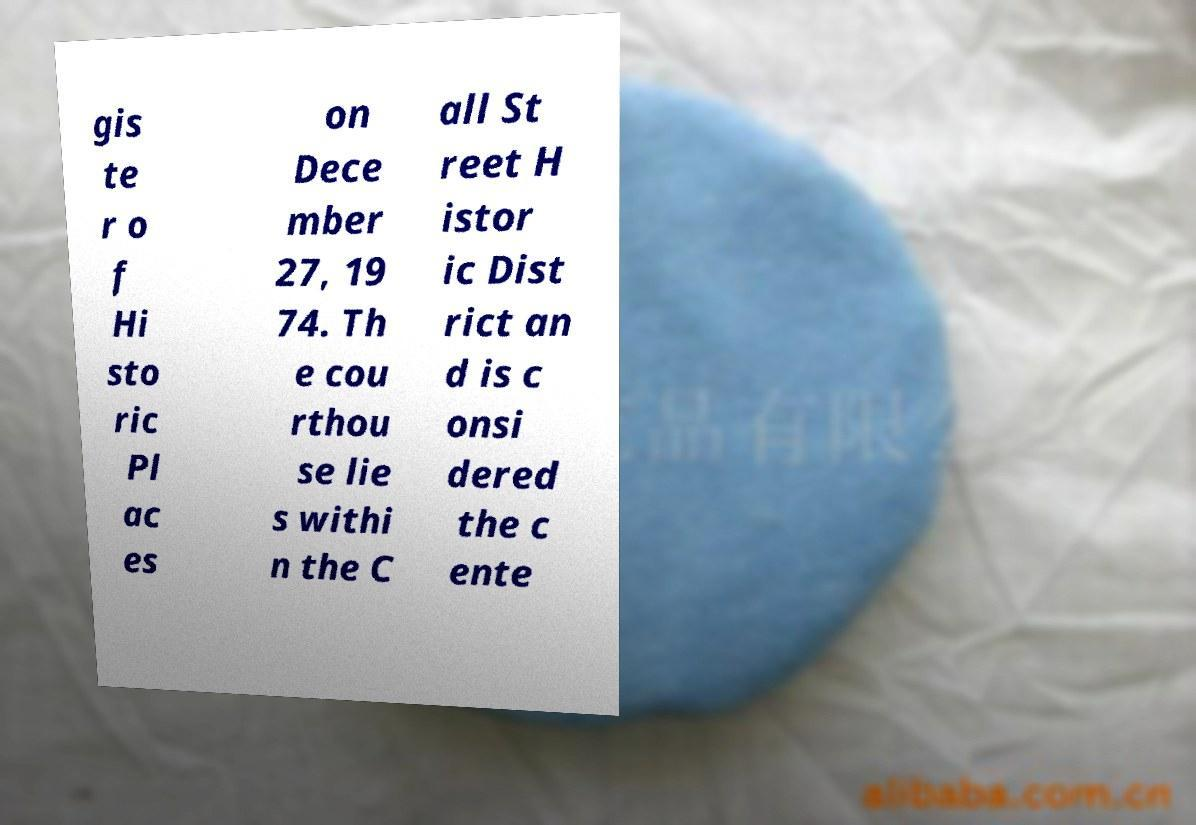Can you read and provide the text displayed in the image?This photo seems to have some interesting text. Can you extract and type it out for me? gis te r o f Hi sto ric Pl ac es on Dece mber 27, 19 74. Th e cou rthou se lie s withi n the C all St reet H istor ic Dist rict an d is c onsi dered the c ente 